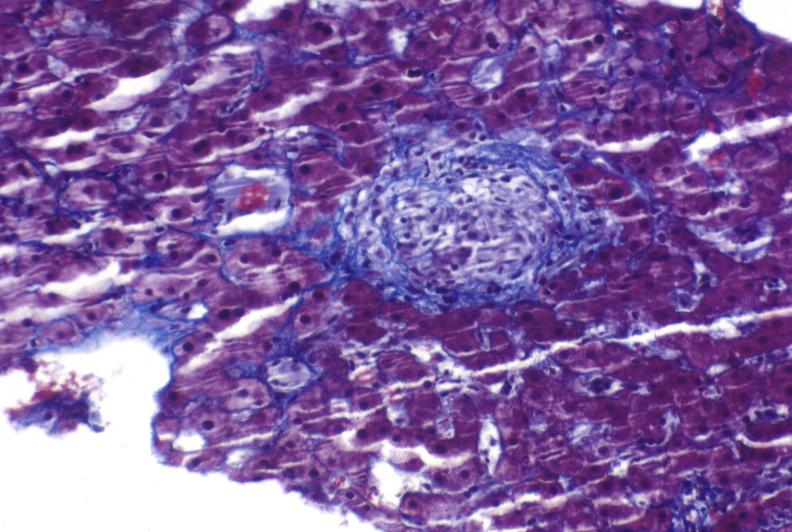s subcapsular hematoma present?
Answer the question using a single word or phrase. No 